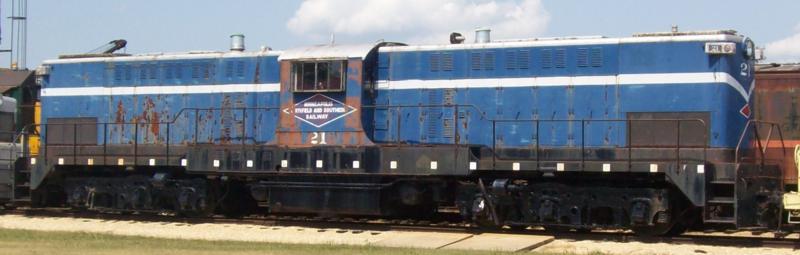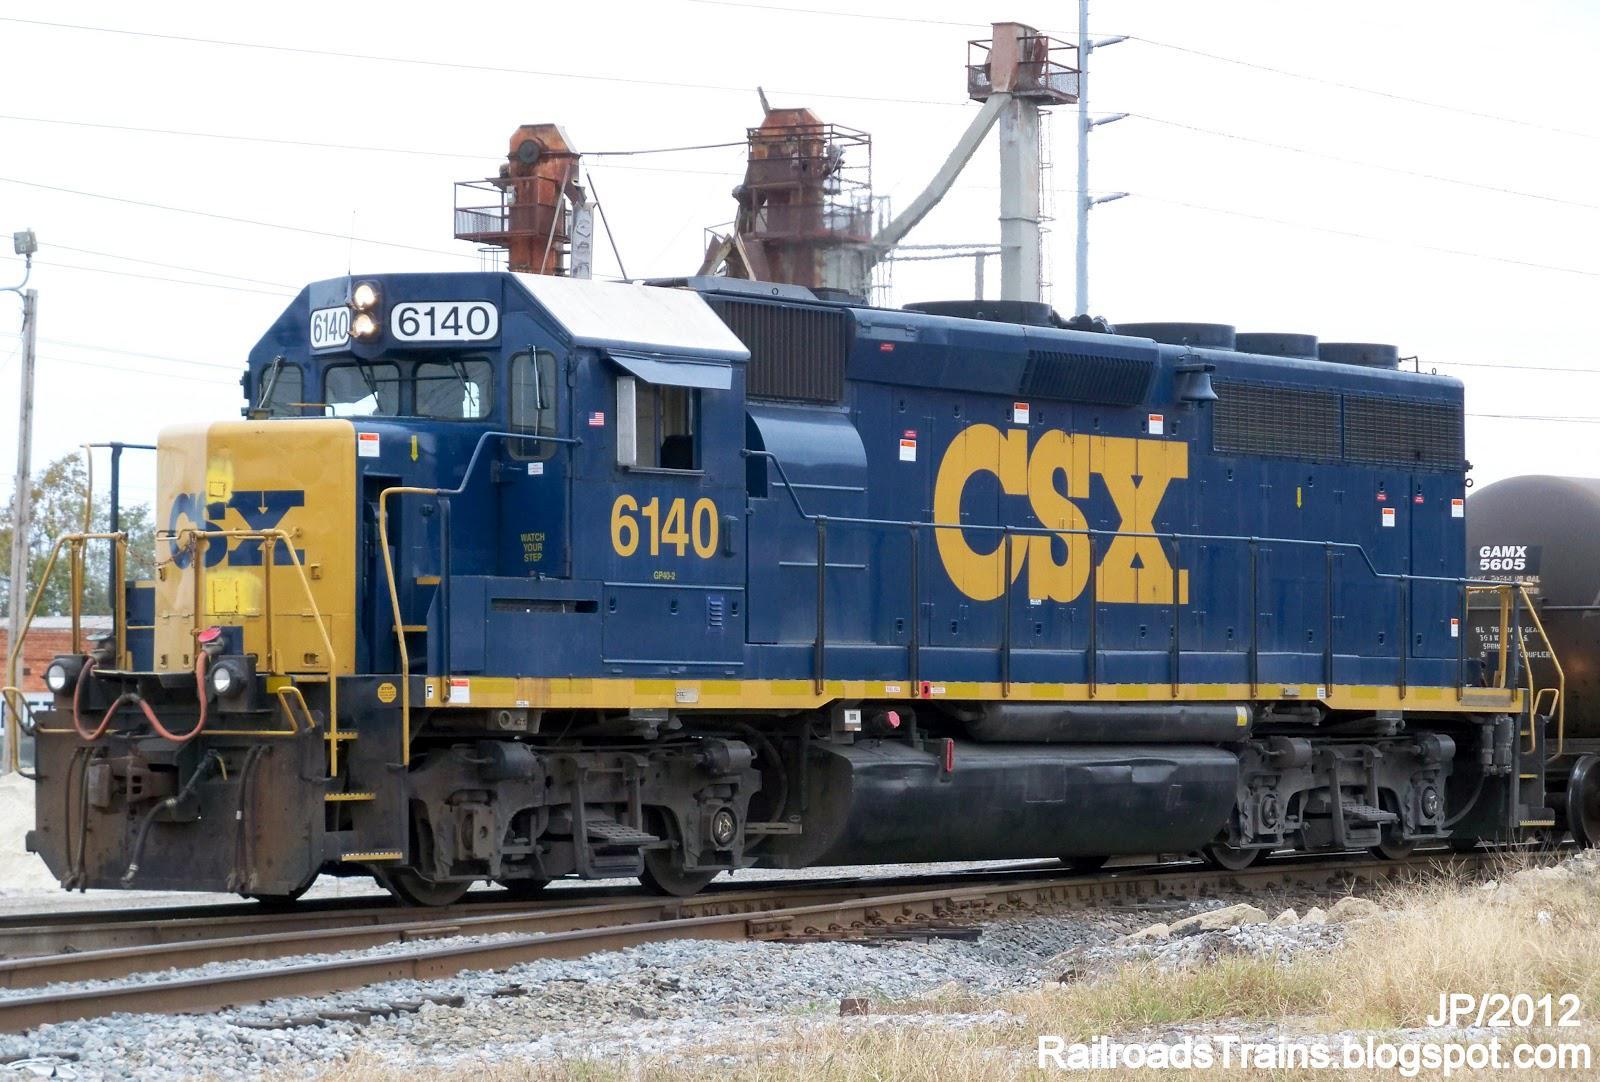The first image is the image on the left, the second image is the image on the right. For the images shown, is this caption "1 locomotive has CSX painted on the side." true? Answer yes or no. Yes. 